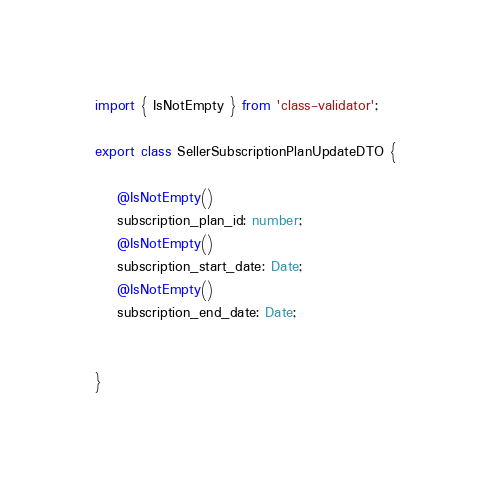Convert code to text. <code><loc_0><loc_0><loc_500><loc_500><_TypeScript_>import { IsNotEmpty } from 'class-validator';

export class SellerSubscriptionPlanUpdateDTO {

    @IsNotEmpty()
    subscription_plan_id: number;
    @IsNotEmpty()
    subscription_start_date: Date;
    @IsNotEmpty()
    subscription_end_date: Date;


}</code> 